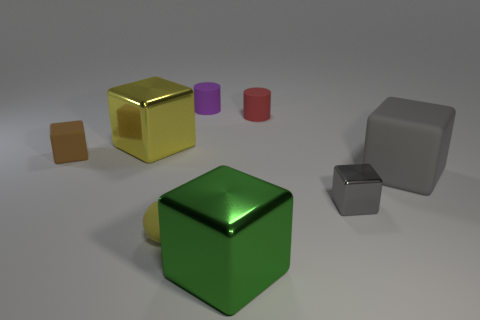There is a matte cylinder on the right side of the green cube; is its size the same as the shiny thing that is in front of the tiny gray object?
Provide a short and direct response. No. What number of cubes are either big yellow things or large gray things?
Provide a short and direct response. 2. Do the gray thing that is in front of the gray matte object and the tiny yellow sphere have the same material?
Keep it short and to the point. No. How many other objects are the same size as the yellow rubber ball?
Make the answer very short. 4. What number of small objects are green rubber objects or yellow metal things?
Provide a succinct answer. 0. Is the tiny sphere the same color as the tiny metal thing?
Your response must be concise. No. Is the number of gray shiny things in front of the ball greater than the number of tiny purple cylinders that are on the right side of the tiny red cylinder?
Ensure brevity in your answer.  No. Does the big metal block right of the large yellow shiny cube have the same color as the small matte ball?
Keep it short and to the point. No. Is there any other thing that has the same color as the small sphere?
Your answer should be compact. Yes. Is the number of big green blocks that are right of the large gray block greater than the number of tiny gray things?
Your answer should be very brief. No. 